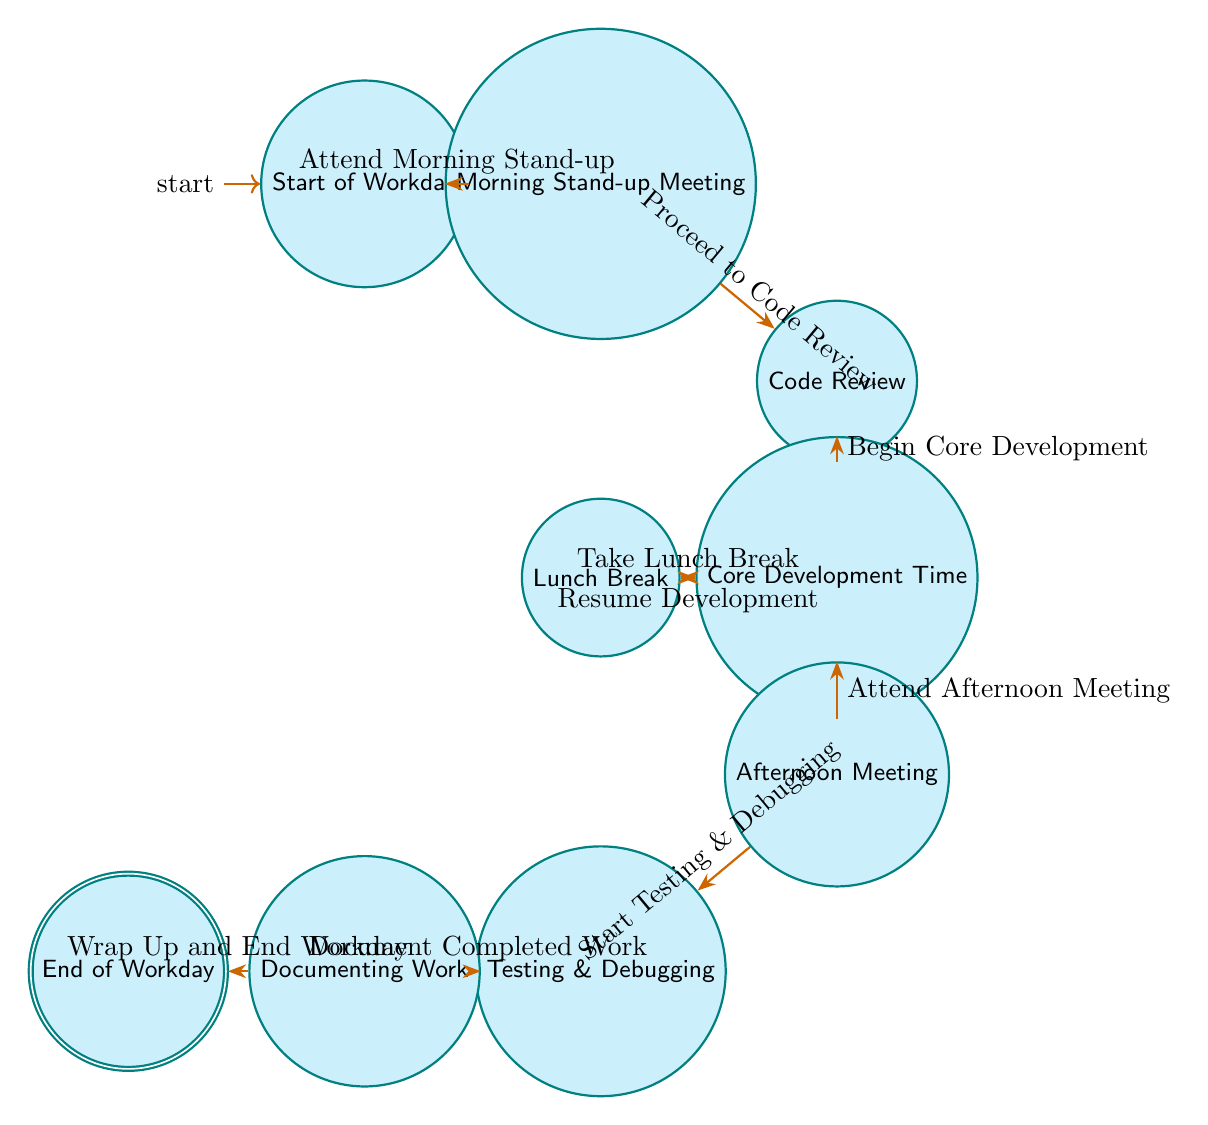What is the first state of the workday? The first state, as indicated in the diagram, is "Start of Workday."
Answer: Start of Workday How many nodes are in the diagram? Counting the nodes displayed in the diagram: Start of Workday, Morning Stand-up Meeting, Code Review, Core Development Time, Lunch Break, Afternoon Meeting, Testing & Debugging, Documenting Work, and End of Workday, we find a total of 9 nodes.
Answer: 9 What state comes after "Code Review"? After "Code Review," the transition to the next state is indicated as "Begin Core Development." Thus, this leads to the state "Core Development Time."
Answer: Core Development Time What is the last activity before ending the workday? The last activity before reaching "End of Workday" is "Document Completed Work," as shown in the transition leading into the final state.
Answer: Document Completed Work How many transitions are there in total? By examining the arrows indicating transitions between states, we count a total of 8 transitions in the diagram.
Answer: 8 What happens after the "Lunch Break"? Following "Lunch Break," the diagram shows a transition labeled "Resume Development," which leads back to the "Core Development Time" state.
Answer: Resume Development Which state follows the "Afternoon Meeting"? The flow in the diagram indicates that after "Afternoon Meeting," the next state is "Testing & Debugging," as specified by the transition connecting the two.
Answer: Testing & Debugging What is the function of the "Morning Stand-up Meeting"? The "Morning Stand-up Meeting" serves as the transition point that initiates the workday routine, specifically moving to the "Code Review" state.
Answer: Proceed to Code Review What is the relationship between "Development" and "Afternoon Meeting"? The relationship shows that "Development" has a transition leading to "Afternoon Meeting," indicating a sequential step in the workday after core development time.
Answer: Attend Afternoon Meeting 